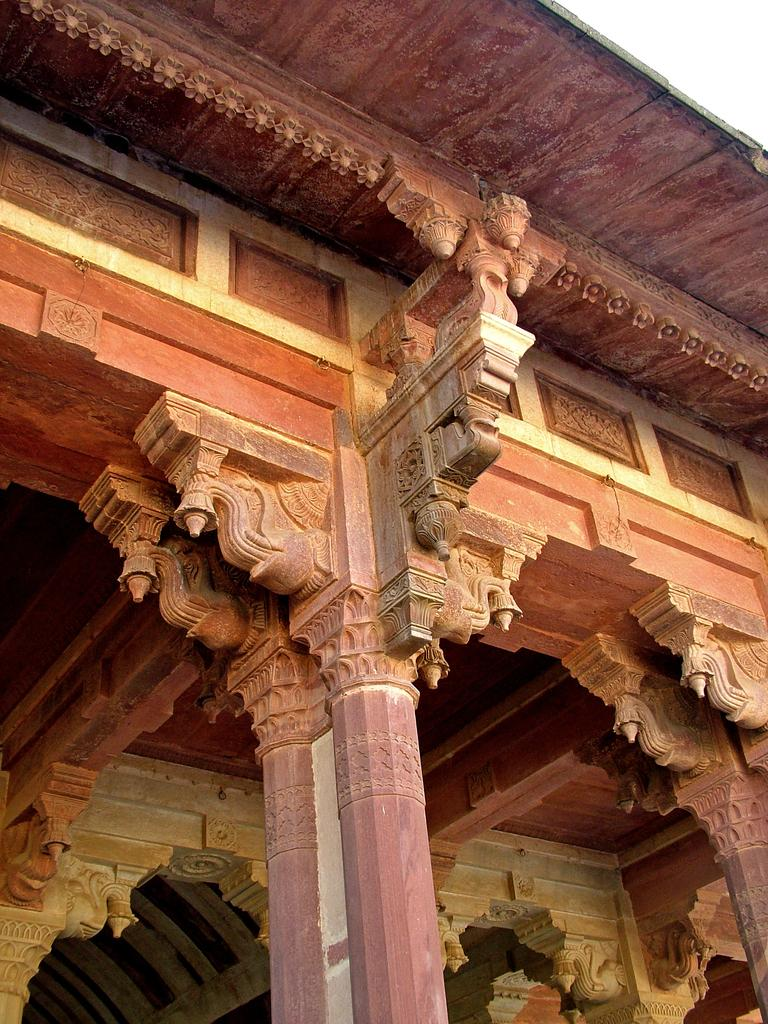What architectural features can be seen in the image? There are pillars in the image. What type of structure do the pillars belong to? The pillars belong to a temple. What smell is associated with the temple in the image? The image does not provide any information about the smell or any sensory experience related to the temple. Therefore, we cannot answer this question based on the given facts. 